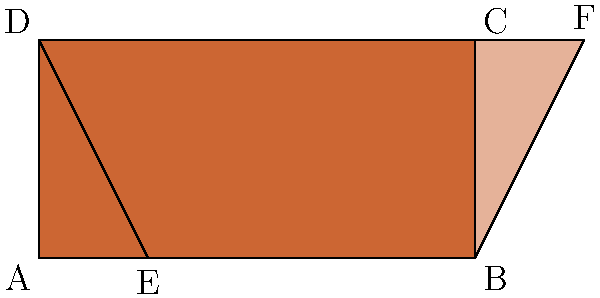A rectangular hair color swatch ABCD is sheared horizontally to create a parallelogram EBFD. If the shear factor is 0.25 and the original rectangle has a width of 4 units and a height of 2 units, what is the area of the resulting parallelogram EBFD? To solve this problem, we'll follow these steps:

1) First, recall that shearing preserves the area of a shape. This means the area of parallelogram EBFD will be equal to the area of rectangle ABCD.

2) Calculate the area of the original rectangle ABCD:
   Area = width × height
   Area = 4 × 2 = 8 square units

3) We don't actually need to calculate the dimensions of the parallelogram, because we know its area will be the same as the rectangle's.

4) However, to verify this conceptually:
   - The base of the parallelogram (EB) is the same as the width of the rectangle (4 units).
   - The height of the parallelogram is the same as the height of the rectangle (2 units).
   - We could calculate: Area of parallelogram = base × height = 4 × 2 = 8 square units

5) Therefore, the area of the parallelogram EBFD is 8 square units.

This problem demonstrates how shearing transformations preserve the area of shapes, which is a useful concept in hair color theory when considering how color swatches might be manipulated or displayed.
Answer: 8 square units 